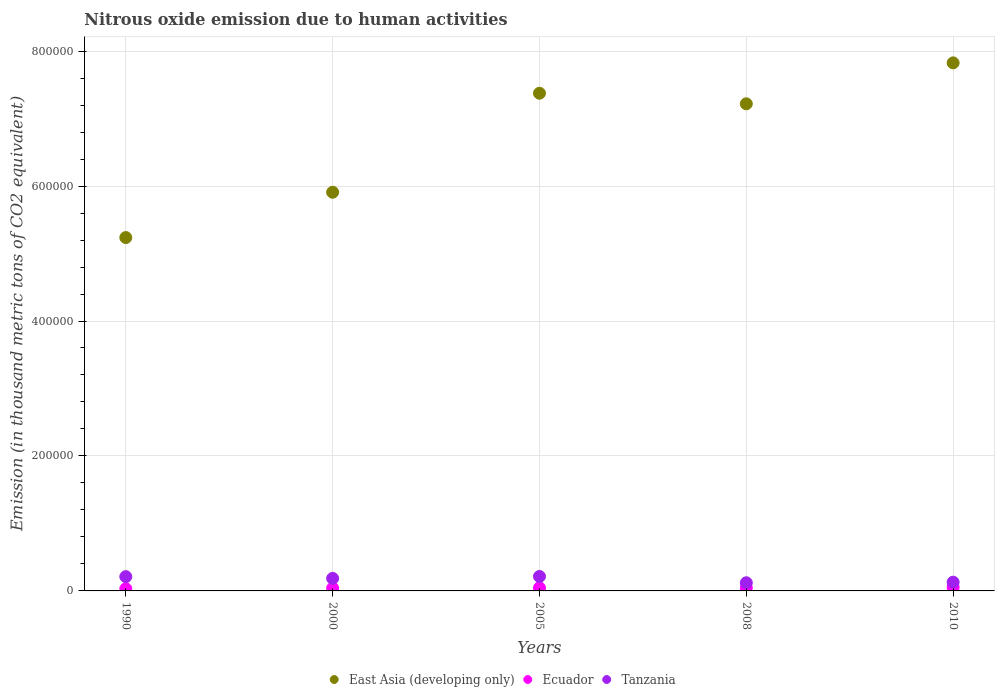What is the amount of nitrous oxide emitted in Tanzania in 2000?
Offer a terse response. 1.86e+04. Across all years, what is the maximum amount of nitrous oxide emitted in Tanzania?
Keep it short and to the point. 2.14e+04. Across all years, what is the minimum amount of nitrous oxide emitted in Ecuador?
Provide a short and direct response. 3194. In which year was the amount of nitrous oxide emitted in Tanzania maximum?
Your answer should be compact. 2005. What is the total amount of nitrous oxide emitted in Ecuador in the graph?
Provide a short and direct response. 2.16e+04. What is the difference between the amount of nitrous oxide emitted in Tanzania in 1990 and that in 2005?
Ensure brevity in your answer.  -300.2. What is the difference between the amount of nitrous oxide emitted in East Asia (developing only) in 1990 and the amount of nitrous oxide emitted in Ecuador in 2000?
Offer a terse response. 5.20e+05. What is the average amount of nitrous oxide emitted in Tanzania per year?
Give a very brief answer. 1.72e+04. In the year 2005, what is the difference between the amount of nitrous oxide emitted in East Asia (developing only) and amount of nitrous oxide emitted in Ecuador?
Your response must be concise. 7.33e+05. What is the ratio of the amount of nitrous oxide emitted in Ecuador in 2005 to that in 2010?
Your response must be concise. 0.86. What is the difference between the highest and the second highest amount of nitrous oxide emitted in Ecuador?
Offer a terse response. 769.6. What is the difference between the highest and the lowest amount of nitrous oxide emitted in Tanzania?
Your response must be concise. 9361.8. Is the sum of the amount of nitrous oxide emitted in Ecuador in 2000 and 2010 greater than the maximum amount of nitrous oxide emitted in Tanzania across all years?
Offer a terse response. No. Does the amount of nitrous oxide emitted in Ecuador monotonically increase over the years?
Provide a short and direct response. No. Is the amount of nitrous oxide emitted in East Asia (developing only) strictly greater than the amount of nitrous oxide emitted in Tanzania over the years?
Your response must be concise. Yes. How many dotlines are there?
Offer a very short reply. 3. How many years are there in the graph?
Your answer should be very brief. 5. How are the legend labels stacked?
Give a very brief answer. Horizontal. What is the title of the graph?
Make the answer very short. Nitrous oxide emission due to human activities. Does "Grenada" appear as one of the legend labels in the graph?
Keep it short and to the point. No. What is the label or title of the Y-axis?
Offer a very short reply. Emission (in thousand metric tons of CO2 equivalent). What is the Emission (in thousand metric tons of CO2 equivalent) in East Asia (developing only) in 1990?
Your answer should be very brief. 5.24e+05. What is the Emission (in thousand metric tons of CO2 equivalent) in Ecuador in 1990?
Keep it short and to the point. 3194. What is the Emission (in thousand metric tons of CO2 equivalent) of Tanzania in 1990?
Keep it short and to the point. 2.11e+04. What is the Emission (in thousand metric tons of CO2 equivalent) of East Asia (developing only) in 2000?
Your answer should be compact. 5.91e+05. What is the Emission (in thousand metric tons of CO2 equivalent) in Ecuador in 2000?
Keep it short and to the point. 4067.7. What is the Emission (in thousand metric tons of CO2 equivalent) in Tanzania in 2000?
Give a very brief answer. 1.86e+04. What is the Emission (in thousand metric tons of CO2 equivalent) in East Asia (developing only) in 2005?
Your answer should be very brief. 7.38e+05. What is the Emission (in thousand metric tons of CO2 equivalent) in Ecuador in 2005?
Your answer should be compact. 4558.5. What is the Emission (in thousand metric tons of CO2 equivalent) in Tanzania in 2005?
Make the answer very short. 2.14e+04. What is the Emission (in thousand metric tons of CO2 equivalent) of East Asia (developing only) in 2008?
Your answer should be very brief. 7.22e+05. What is the Emission (in thousand metric tons of CO2 equivalent) in Ecuador in 2008?
Your answer should be very brief. 4488.1. What is the Emission (in thousand metric tons of CO2 equivalent) of Tanzania in 2008?
Make the answer very short. 1.21e+04. What is the Emission (in thousand metric tons of CO2 equivalent) of East Asia (developing only) in 2010?
Ensure brevity in your answer.  7.83e+05. What is the Emission (in thousand metric tons of CO2 equivalent) of Ecuador in 2010?
Your response must be concise. 5328.1. What is the Emission (in thousand metric tons of CO2 equivalent) in Tanzania in 2010?
Ensure brevity in your answer.  1.29e+04. Across all years, what is the maximum Emission (in thousand metric tons of CO2 equivalent) in East Asia (developing only)?
Make the answer very short. 7.83e+05. Across all years, what is the maximum Emission (in thousand metric tons of CO2 equivalent) in Ecuador?
Keep it short and to the point. 5328.1. Across all years, what is the maximum Emission (in thousand metric tons of CO2 equivalent) of Tanzania?
Give a very brief answer. 2.14e+04. Across all years, what is the minimum Emission (in thousand metric tons of CO2 equivalent) in East Asia (developing only)?
Provide a succinct answer. 5.24e+05. Across all years, what is the minimum Emission (in thousand metric tons of CO2 equivalent) of Ecuador?
Your response must be concise. 3194. Across all years, what is the minimum Emission (in thousand metric tons of CO2 equivalent) in Tanzania?
Give a very brief answer. 1.21e+04. What is the total Emission (in thousand metric tons of CO2 equivalent) of East Asia (developing only) in the graph?
Provide a short and direct response. 3.36e+06. What is the total Emission (in thousand metric tons of CO2 equivalent) in Ecuador in the graph?
Your answer should be very brief. 2.16e+04. What is the total Emission (in thousand metric tons of CO2 equivalent) in Tanzania in the graph?
Make the answer very short. 8.62e+04. What is the difference between the Emission (in thousand metric tons of CO2 equivalent) of East Asia (developing only) in 1990 and that in 2000?
Your response must be concise. -6.71e+04. What is the difference between the Emission (in thousand metric tons of CO2 equivalent) of Ecuador in 1990 and that in 2000?
Your answer should be compact. -873.7. What is the difference between the Emission (in thousand metric tons of CO2 equivalent) of Tanzania in 1990 and that in 2000?
Your answer should be compact. 2557. What is the difference between the Emission (in thousand metric tons of CO2 equivalent) of East Asia (developing only) in 1990 and that in 2005?
Your answer should be very brief. -2.14e+05. What is the difference between the Emission (in thousand metric tons of CO2 equivalent) of Ecuador in 1990 and that in 2005?
Your answer should be very brief. -1364.5. What is the difference between the Emission (in thousand metric tons of CO2 equivalent) in Tanzania in 1990 and that in 2005?
Provide a short and direct response. -300.2. What is the difference between the Emission (in thousand metric tons of CO2 equivalent) of East Asia (developing only) in 1990 and that in 2008?
Provide a succinct answer. -1.98e+05. What is the difference between the Emission (in thousand metric tons of CO2 equivalent) of Ecuador in 1990 and that in 2008?
Your response must be concise. -1294.1. What is the difference between the Emission (in thousand metric tons of CO2 equivalent) of Tanzania in 1990 and that in 2008?
Provide a short and direct response. 9061.6. What is the difference between the Emission (in thousand metric tons of CO2 equivalent) of East Asia (developing only) in 1990 and that in 2010?
Ensure brevity in your answer.  -2.59e+05. What is the difference between the Emission (in thousand metric tons of CO2 equivalent) in Ecuador in 1990 and that in 2010?
Make the answer very short. -2134.1. What is the difference between the Emission (in thousand metric tons of CO2 equivalent) in Tanzania in 1990 and that in 2010?
Give a very brief answer. 8189.7. What is the difference between the Emission (in thousand metric tons of CO2 equivalent) of East Asia (developing only) in 2000 and that in 2005?
Offer a very short reply. -1.47e+05. What is the difference between the Emission (in thousand metric tons of CO2 equivalent) in Ecuador in 2000 and that in 2005?
Make the answer very short. -490.8. What is the difference between the Emission (in thousand metric tons of CO2 equivalent) in Tanzania in 2000 and that in 2005?
Make the answer very short. -2857.2. What is the difference between the Emission (in thousand metric tons of CO2 equivalent) of East Asia (developing only) in 2000 and that in 2008?
Provide a succinct answer. -1.31e+05. What is the difference between the Emission (in thousand metric tons of CO2 equivalent) of Ecuador in 2000 and that in 2008?
Offer a terse response. -420.4. What is the difference between the Emission (in thousand metric tons of CO2 equivalent) of Tanzania in 2000 and that in 2008?
Give a very brief answer. 6504.6. What is the difference between the Emission (in thousand metric tons of CO2 equivalent) of East Asia (developing only) in 2000 and that in 2010?
Give a very brief answer. -1.92e+05. What is the difference between the Emission (in thousand metric tons of CO2 equivalent) of Ecuador in 2000 and that in 2010?
Make the answer very short. -1260.4. What is the difference between the Emission (in thousand metric tons of CO2 equivalent) of Tanzania in 2000 and that in 2010?
Provide a succinct answer. 5632.7. What is the difference between the Emission (in thousand metric tons of CO2 equivalent) of East Asia (developing only) in 2005 and that in 2008?
Make the answer very short. 1.57e+04. What is the difference between the Emission (in thousand metric tons of CO2 equivalent) of Ecuador in 2005 and that in 2008?
Your answer should be very brief. 70.4. What is the difference between the Emission (in thousand metric tons of CO2 equivalent) in Tanzania in 2005 and that in 2008?
Your answer should be very brief. 9361.8. What is the difference between the Emission (in thousand metric tons of CO2 equivalent) in East Asia (developing only) in 2005 and that in 2010?
Offer a terse response. -4.50e+04. What is the difference between the Emission (in thousand metric tons of CO2 equivalent) in Ecuador in 2005 and that in 2010?
Make the answer very short. -769.6. What is the difference between the Emission (in thousand metric tons of CO2 equivalent) of Tanzania in 2005 and that in 2010?
Ensure brevity in your answer.  8489.9. What is the difference between the Emission (in thousand metric tons of CO2 equivalent) in East Asia (developing only) in 2008 and that in 2010?
Provide a succinct answer. -6.06e+04. What is the difference between the Emission (in thousand metric tons of CO2 equivalent) of Ecuador in 2008 and that in 2010?
Ensure brevity in your answer.  -840. What is the difference between the Emission (in thousand metric tons of CO2 equivalent) of Tanzania in 2008 and that in 2010?
Keep it short and to the point. -871.9. What is the difference between the Emission (in thousand metric tons of CO2 equivalent) in East Asia (developing only) in 1990 and the Emission (in thousand metric tons of CO2 equivalent) in Ecuador in 2000?
Provide a short and direct response. 5.20e+05. What is the difference between the Emission (in thousand metric tons of CO2 equivalent) of East Asia (developing only) in 1990 and the Emission (in thousand metric tons of CO2 equivalent) of Tanzania in 2000?
Keep it short and to the point. 5.05e+05. What is the difference between the Emission (in thousand metric tons of CO2 equivalent) in Ecuador in 1990 and the Emission (in thousand metric tons of CO2 equivalent) in Tanzania in 2000?
Offer a terse response. -1.54e+04. What is the difference between the Emission (in thousand metric tons of CO2 equivalent) of East Asia (developing only) in 1990 and the Emission (in thousand metric tons of CO2 equivalent) of Ecuador in 2005?
Your response must be concise. 5.19e+05. What is the difference between the Emission (in thousand metric tons of CO2 equivalent) in East Asia (developing only) in 1990 and the Emission (in thousand metric tons of CO2 equivalent) in Tanzania in 2005?
Offer a terse response. 5.02e+05. What is the difference between the Emission (in thousand metric tons of CO2 equivalent) of Ecuador in 1990 and the Emission (in thousand metric tons of CO2 equivalent) of Tanzania in 2005?
Offer a very short reply. -1.82e+04. What is the difference between the Emission (in thousand metric tons of CO2 equivalent) in East Asia (developing only) in 1990 and the Emission (in thousand metric tons of CO2 equivalent) in Ecuador in 2008?
Keep it short and to the point. 5.19e+05. What is the difference between the Emission (in thousand metric tons of CO2 equivalent) of East Asia (developing only) in 1990 and the Emission (in thousand metric tons of CO2 equivalent) of Tanzania in 2008?
Your answer should be compact. 5.12e+05. What is the difference between the Emission (in thousand metric tons of CO2 equivalent) in Ecuador in 1990 and the Emission (in thousand metric tons of CO2 equivalent) in Tanzania in 2008?
Your answer should be very brief. -8881.6. What is the difference between the Emission (in thousand metric tons of CO2 equivalent) in East Asia (developing only) in 1990 and the Emission (in thousand metric tons of CO2 equivalent) in Ecuador in 2010?
Provide a short and direct response. 5.18e+05. What is the difference between the Emission (in thousand metric tons of CO2 equivalent) in East Asia (developing only) in 1990 and the Emission (in thousand metric tons of CO2 equivalent) in Tanzania in 2010?
Keep it short and to the point. 5.11e+05. What is the difference between the Emission (in thousand metric tons of CO2 equivalent) in Ecuador in 1990 and the Emission (in thousand metric tons of CO2 equivalent) in Tanzania in 2010?
Ensure brevity in your answer.  -9753.5. What is the difference between the Emission (in thousand metric tons of CO2 equivalent) of East Asia (developing only) in 2000 and the Emission (in thousand metric tons of CO2 equivalent) of Ecuador in 2005?
Give a very brief answer. 5.86e+05. What is the difference between the Emission (in thousand metric tons of CO2 equivalent) of East Asia (developing only) in 2000 and the Emission (in thousand metric tons of CO2 equivalent) of Tanzania in 2005?
Offer a terse response. 5.69e+05. What is the difference between the Emission (in thousand metric tons of CO2 equivalent) in Ecuador in 2000 and the Emission (in thousand metric tons of CO2 equivalent) in Tanzania in 2005?
Your response must be concise. -1.74e+04. What is the difference between the Emission (in thousand metric tons of CO2 equivalent) of East Asia (developing only) in 2000 and the Emission (in thousand metric tons of CO2 equivalent) of Ecuador in 2008?
Provide a succinct answer. 5.86e+05. What is the difference between the Emission (in thousand metric tons of CO2 equivalent) in East Asia (developing only) in 2000 and the Emission (in thousand metric tons of CO2 equivalent) in Tanzania in 2008?
Ensure brevity in your answer.  5.79e+05. What is the difference between the Emission (in thousand metric tons of CO2 equivalent) in Ecuador in 2000 and the Emission (in thousand metric tons of CO2 equivalent) in Tanzania in 2008?
Offer a terse response. -8007.9. What is the difference between the Emission (in thousand metric tons of CO2 equivalent) in East Asia (developing only) in 2000 and the Emission (in thousand metric tons of CO2 equivalent) in Ecuador in 2010?
Offer a very short reply. 5.85e+05. What is the difference between the Emission (in thousand metric tons of CO2 equivalent) in East Asia (developing only) in 2000 and the Emission (in thousand metric tons of CO2 equivalent) in Tanzania in 2010?
Your answer should be very brief. 5.78e+05. What is the difference between the Emission (in thousand metric tons of CO2 equivalent) in Ecuador in 2000 and the Emission (in thousand metric tons of CO2 equivalent) in Tanzania in 2010?
Ensure brevity in your answer.  -8879.8. What is the difference between the Emission (in thousand metric tons of CO2 equivalent) in East Asia (developing only) in 2005 and the Emission (in thousand metric tons of CO2 equivalent) in Ecuador in 2008?
Your answer should be compact. 7.33e+05. What is the difference between the Emission (in thousand metric tons of CO2 equivalent) in East Asia (developing only) in 2005 and the Emission (in thousand metric tons of CO2 equivalent) in Tanzania in 2008?
Your answer should be compact. 7.25e+05. What is the difference between the Emission (in thousand metric tons of CO2 equivalent) in Ecuador in 2005 and the Emission (in thousand metric tons of CO2 equivalent) in Tanzania in 2008?
Offer a terse response. -7517.1. What is the difference between the Emission (in thousand metric tons of CO2 equivalent) of East Asia (developing only) in 2005 and the Emission (in thousand metric tons of CO2 equivalent) of Ecuador in 2010?
Offer a very short reply. 7.32e+05. What is the difference between the Emission (in thousand metric tons of CO2 equivalent) in East Asia (developing only) in 2005 and the Emission (in thousand metric tons of CO2 equivalent) in Tanzania in 2010?
Keep it short and to the point. 7.25e+05. What is the difference between the Emission (in thousand metric tons of CO2 equivalent) in Ecuador in 2005 and the Emission (in thousand metric tons of CO2 equivalent) in Tanzania in 2010?
Your response must be concise. -8389. What is the difference between the Emission (in thousand metric tons of CO2 equivalent) in East Asia (developing only) in 2008 and the Emission (in thousand metric tons of CO2 equivalent) in Ecuador in 2010?
Keep it short and to the point. 7.17e+05. What is the difference between the Emission (in thousand metric tons of CO2 equivalent) of East Asia (developing only) in 2008 and the Emission (in thousand metric tons of CO2 equivalent) of Tanzania in 2010?
Your answer should be very brief. 7.09e+05. What is the difference between the Emission (in thousand metric tons of CO2 equivalent) in Ecuador in 2008 and the Emission (in thousand metric tons of CO2 equivalent) in Tanzania in 2010?
Offer a very short reply. -8459.4. What is the average Emission (in thousand metric tons of CO2 equivalent) in East Asia (developing only) per year?
Make the answer very short. 6.71e+05. What is the average Emission (in thousand metric tons of CO2 equivalent) in Ecuador per year?
Provide a succinct answer. 4327.28. What is the average Emission (in thousand metric tons of CO2 equivalent) of Tanzania per year?
Your response must be concise. 1.72e+04. In the year 1990, what is the difference between the Emission (in thousand metric tons of CO2 equivalent) of East Asia (developing only) and Emission (in thousand metric tons of CO2 equivalent) of Ecuador?
Keep it short and to the point. 5.20e+05. In the year 1990, what is the difference between the Emission (in thousand metric tons of CO2 equivalent) in East Asia (developing only) and Emission (in thousand metric tons of CO2 equivalent) in Tanzania?
Your response must be concise. 5.03e+05. In the year 1990, what is the difference between the Emission (in thousand metric tons of CO2 equivalent) in Ecuador and Emission (in thousand metric tons of CO2 equivalent) in Tanzania?
Offer a very short reply. -1.79e+04. In the year 2000, what is the difference between the Emission (in thousand metric tons of CO2 equivalent) of East Asia (developing only) and Emission (in thousand metric tons of CO2 equivalent) of Ecuador?
Keep it short and to the point. 5.87e+05. In the year 2000, what is the difference between the Emission (in thousand metric tons of CO2 equivalent) in East Asia (developing only) and Emission (in thousand metric tons of CO2 equivalent) in Tanzania?
Offer a terse response. 5.72e+05. In the year 2000, what is the difference between the Emission (in thousand metric tons of CO2 equivalent) in Ecuador and Emission (in thousand metric tons of CO2 equivalent) in Tanzania?
Provide a succinct answer. -1.45e+04. In the year 2005, what is the difference between the Emission (in thousand metric tons of CO2 equivalent) in East Asia (developing only) and Emission (in thousand metric tons of CO2 equivalent) in Ecuador?
Your answer should be very brief. 7.33e+05. In the year 2005, what is the difference between the Emission (in thousand metric tons of CO2 equivalent) in East Asia (developing only) and Emission (in thousand metric tons of CO2 equivalent) in Tanzania?
Your answer should be very brief. 7.16e+05. In the year 2005, what is the difference between the Emission (in thousand metric tons of CO2 equivalent) in Ecuador and Emission (in thousand metric tons of CO2 equivalent) in Tanzania?
Your answer should be compact. -1.69e+04. In the year 2008, what is the difference between the Emission (in thousand metric tons of CO2 equivalent) in East Asia (developing only) and Emission (in thousand metric tons of CO2 equivalent) in Ecuador?
Provide a succinct answer. 7.17e+05. In the year 2008, what is the difference between the Emission (in thousand metric tons of CO2 equivalent) in East Asia (developing only) and Emission (in thousand metric tons of CO2 equivalent) in Tanzania?
Your answer should be compact. 7.10e+05. In the year 2008, what is the difference between the Emission (in thousand metric tons of CO2 equivalent) in Ecuador and Emission (in thousand metric tons of CO2 equivalent) in Tanzania?
Your response must be concise. -7587.5. In the year 2010, what is the difference between the Emission (in thousand metric tons of CO2 equivalent) in East Asia (developing only) and Emission (in thousand metric tons of CO2 equivalent) in Ecuador?
Make the answer very short. 7.77e+05. In the year 2010, what is the difference between the Emission (in thousand metric tons of CO2 equivalent) in East Asia (developing only) and Emission (in thousand metric tons of CO2 equivalent) in Tanzania?
Offer a terse response. 7.70e+05. In the year 2010, what is the difference between the Emission (in thousand metric tons of CO2 equivalent) of Ecuador and Emission (in thousand metric tons of CO2 equivalent) of Tanzania?
Make the answer very short. -7619.4. What is the ratio of the Emission (in thousand metric tons of CO2 equivalent) in East Asia (developing only) in 1990 to that in 2000?
Your answer should be compact. 0.89. What is the ratio of the Emission (in thousand metric tons of CO2 equivalent) of Ecuador in 1990 to that in 2000?
Your answer should be compact. 0.79. What is the ratio of the Emission (in thousand metric tons of CO2 equivalent) of Tanzania in 1990 to that in 2000?
Keep it short and to the point. 1.14. What is the ratio of the Emission (in thousand metric tons of CO2 equivalent) in East Asia (developing only) in 1990 to that in 2005?
Your response must be concise. 0.71. What is the ratio of the Emission (in thousand metric tons of CO2 equivalent) in Ecuador in 1990 to that in 2005?
Your answer should be very brief. 0.7. What is the ratio of the Emission (in thousand metric tons of CO2 equivalent) of Tanzania in 1990 to that in 2005?
Your answer should be compact. 0.99. What is the ratio of the Emission (in thousand metric tons of CO2 equivalent) in East Asia (developing only) in 1990 to that in 2008?
Your response must be concise. 0.73. What is the ratio of the Emission (in thousand metric tons of CO2 equivalent) in Ecuador in 1990 to that in 2008?
Offer a terse response. 0.71. What is the ratio of the Emission (in thousand metric tons of CO2 equivalent) of Tanzania in 1990 to that in 2008?
Make the answer very short. 1.75. What is the ratio of the Emission (in thousand metric tons of CO2 equivalent) in East Asia (developing only) in 1990 to that in 2010?
Your answer should be compact. 0.67. What is the ratio of the Emission (in thousand metric tons of CO2 equivalent) of Ecuador in 1990 to that in 2010?
Your response must be concise. 0.6. What is the ratio of the Emission (in thousand metric tons of CO2 equivalent) of Tanzania in 1990 to that in 2010?
Offer a terse response. 1.63. What is the ratio of the Emission (in thousand metric tons of CO2 equivalent) in East Asia (developing only) in 2000 to that in 2005?
Your answer should be very brief. 0.8. What is the ratio of the Emission (in thousand metric tons of CO2 equivalent) in Ecuador in 2000 to that in 2005?
Provide a short and direct response. 0.89. What is the ratio of the Emission (in thousand metric tons of CO2 equivalent) in Tanzania in 2000 to that in 2005?
Your response must be concise. 0.87. What is the ratio of the Emission (in thousand metric tons of CO2 equivalent) in East Asia (developing only) in 2000 to that in 2008?
Provide a succinct answer. 0.82. What is the ratio of the Emission (in thousand metric tons of CO2 equivalent) in Ecuador in 2000 to that in 2008?
Your answer should be compact. 0.91. What is the ratio of the Emission (in thousand metric tons of CO2 equivalent) in Tanzania in 2000 to that in 2008?
Your response must be concise. 1.54. What is the ratio of the Emission (in thousand metric tons of CO2 equivalent) in East Asia (developing only) in 2000 to that in 2010?
Your answer should be very brief. 0.76. What is the ratio of the Emission (in thousand metric tons of CO2 equivalent) in Ecuador in 2000 to that in 2010?
Give a very brief answer. 0.76. What is the ratio of the Emission (in thousand metric tons of CO2 equivalent) of Tanzania in 2000 to that in 2010?
Offer a terse response. 1.44. What is the ratio of the Emission (in thousand metric tons of CO2 equivalent) of East Asia (developing only) in 2005 to that in 2008?
Your response must be concise. 1.02. What is the ratio of the Emission (in thousand metric tons of CO2 equivalent) of Ecuador in 2005 to that in 2008?
Provide a succinct answer. 1.02. What is the ratio of the Emission (in thousand metric tons of CO2 equivalent) of Tanzania in 2005 to that in 2008?
Your answer should be very brief. 1.78. What is the ratio of the Emission (in thousand metric tons of CO2 equivalent) of East Asia (developing only) in 2005 to that in 2010?
Offer a very short reply. 0.94. What is the ratio of the Emission (in thousand metric tons of CO2 equivalent) of Ecuador in 2005 to that in 2010?
Keep it short and to the point. 0.86. What is the ratio of the Emission (in thousand metric tons of CO2 equivalent) in Tanzania in 2005 to that in 2010?
Offer a terse response. 1.66. What is the ratio of the Emission (in thousand metric tons of CO2 equivalent) in East Asia (developing only) in 2008 to that in 2010?
Your answer should be very brief. 0.92. What is the ratio of the Emission (in thousand metric tons of CO2 equivalent) of Ecuador in 2008 to that in 2010?
Give a very brief answer. 0.84. What is the ratio of the Emission (in thousand metric tons of CO2 equivalent) in Tanzania in 2008 to that in 2010?
Make the answer very short. 0.93. What is the difference between the highest and the second highest Emission (in thousand metric tons of CO2 equivalent) in East Asia (developing only)?
Provide a short and direct response. 4.50e+04. What is the difference between the highest and the second highest Emission (in thousand metric tons of CO2 equivalent) of Ecuador?
Keep it short and to the point. 769.6. What is the difference between the highest and the second highest Emission (in thousand metric tons of CO2 equivalent) in Tanzania?
Keep it short and to the point. 300.2. What is the difference between the highest and the lowest Emission (in thousand metric tons of CO2 equivalent) in East Asia (developing only)?
Your answer should be very brief. 2.59e+05. What is the difference between the highest and the lowest Emission (in thousand metric tons of CO2 equivalent) in Ecuador?
Your response must be concise. 2134.1. What is the difference between the highest and the lowest Emission (in thousand metric tons of CO2 equivalent) of Tanzania?
Your answer should be compact. 9361.8. 